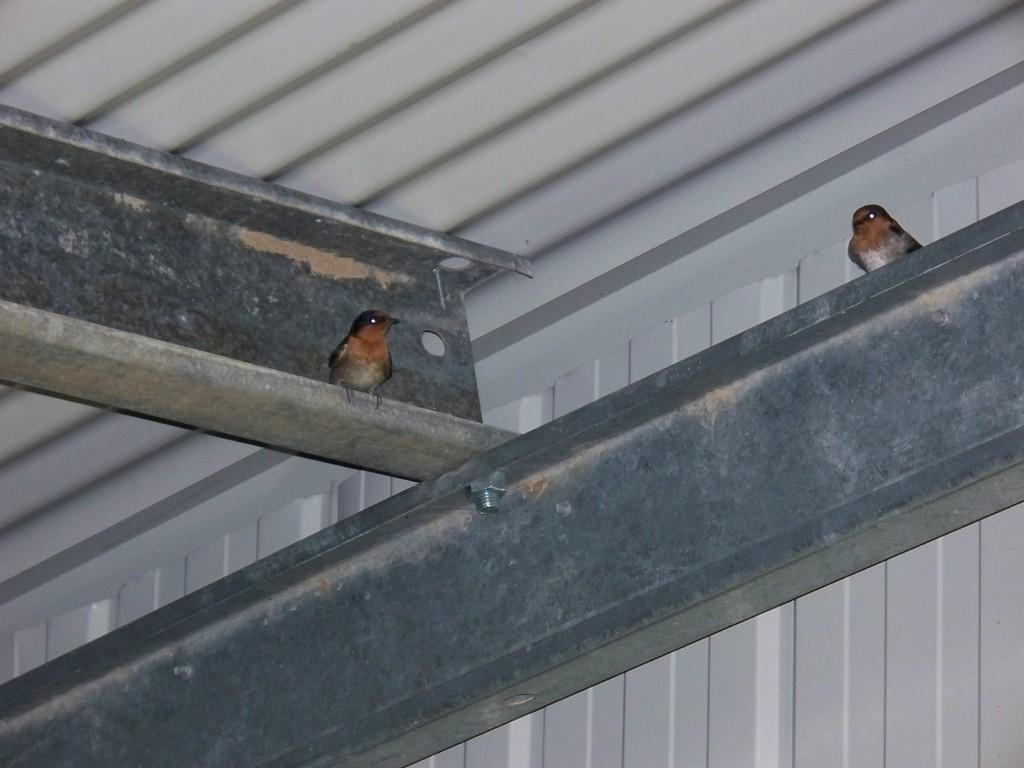What objects are made of iron metal in the image? There are two iron metal rods in the image. What type of structure can be seen in the image? There is a shed in the image. Can you describe the birds in the image? There are two birds, one standing on an iron rod on the right side of the image and another standing on an iron rod on the left side of the image. How does the bird on the right side of the image draw attention to itself? The image does not provide information about the bird drawing attention to itself; it only shows the bird standing on an iron rod. 